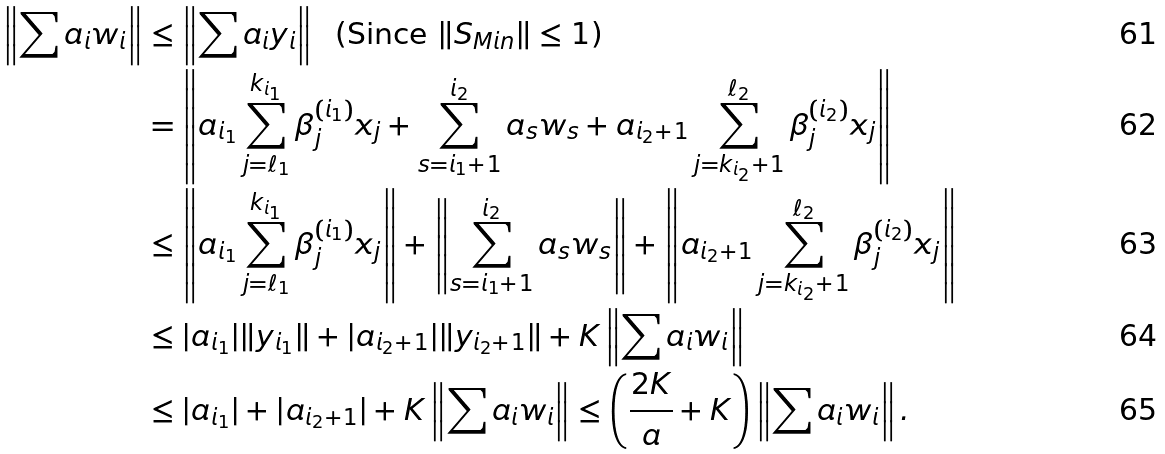<formula> <loc_0><loc_0><loc_500><loc_500>\left \| \sum a _ { i } w _ { i } \right \| & \leq \left \| \sum a _ { i } y _ { i } \right \| \text {\ \ (Since $\|S_{Min}\|\leq 1$)} \\ & = \left \| a _ { i _ { 1 } } \sum _ { j = \ell _ { 1 } } ^ { k _ { i _ { 1 } } } \beta _ { j } ^ { ( i _ { 1 } ) } x _ { j } + \sum _ { s = i _ { 1 } + 1 } ^ { i _ { 2 } } a _ { s } w _ { s } + a _ { i _ { 2 } + 1 } \sum _ { j = k _ { i _ { 2 } } + 1 } ^ { \ell _ { 2 } } \beta _ { j } ^ { ( i _ { 2 } ) } x _ { j } \right \| \\ & \leq \left \| a _ { i _ { 1 } } \sum _ { j = \ell _ { 1 } } ^ { k _ { i _ { 1 } } } \beta _ { j } ^ { ( i _ { 1 } ) } x _ { j } \right \| + \left \| \sum _ { s = i _ { 1 } + 1 } ^ { i _ { 2 } } a _ { s } w _ { s } \right \| + \left \| a _ { i _ { 2 } + 1 } \sum _ { j = k _ { i _ { 2 } } + 1 } ^ { \ell _ { 2 } } \beta _ { j } ^ { ( i _ { 2 } ) } x _ { j } \right \| \\ & \leq | a _ { i _ { 1 } } | \| y _ { i _ { 1 } } \| + | a _ { i _ { 2 } + 1 } | \| y _ { i _ { 2 } + 1 } \| + K \left \| \sum a _ { i } w _ { i } \right \| \\ & \leq | a _ { i _ { 1 } } | + | a _ { i _ { 2 } + 1 } | + K \left \| \sum a _ { i } w _ { i } \right \| \leq \left ( \frac { 2 K } a + K \right ) \left \| \sum a _ { i } w _ { i } \right \| .</formula> 